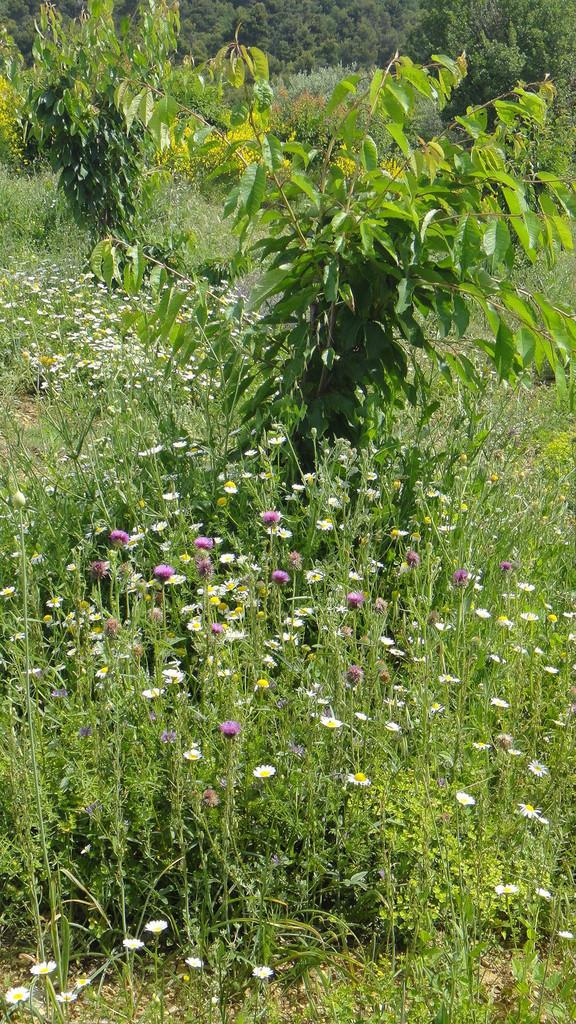What type of plants are at the bottom of the image? There are plants with flowers at the bottom of the image. What can be seen in the background of the image? There are trees in the background of the image. What type of cable is being used to support the nation in the image? There is no mention of a nation or a cable in the image; it features plants with flowers at the bottom and trees in the background. 